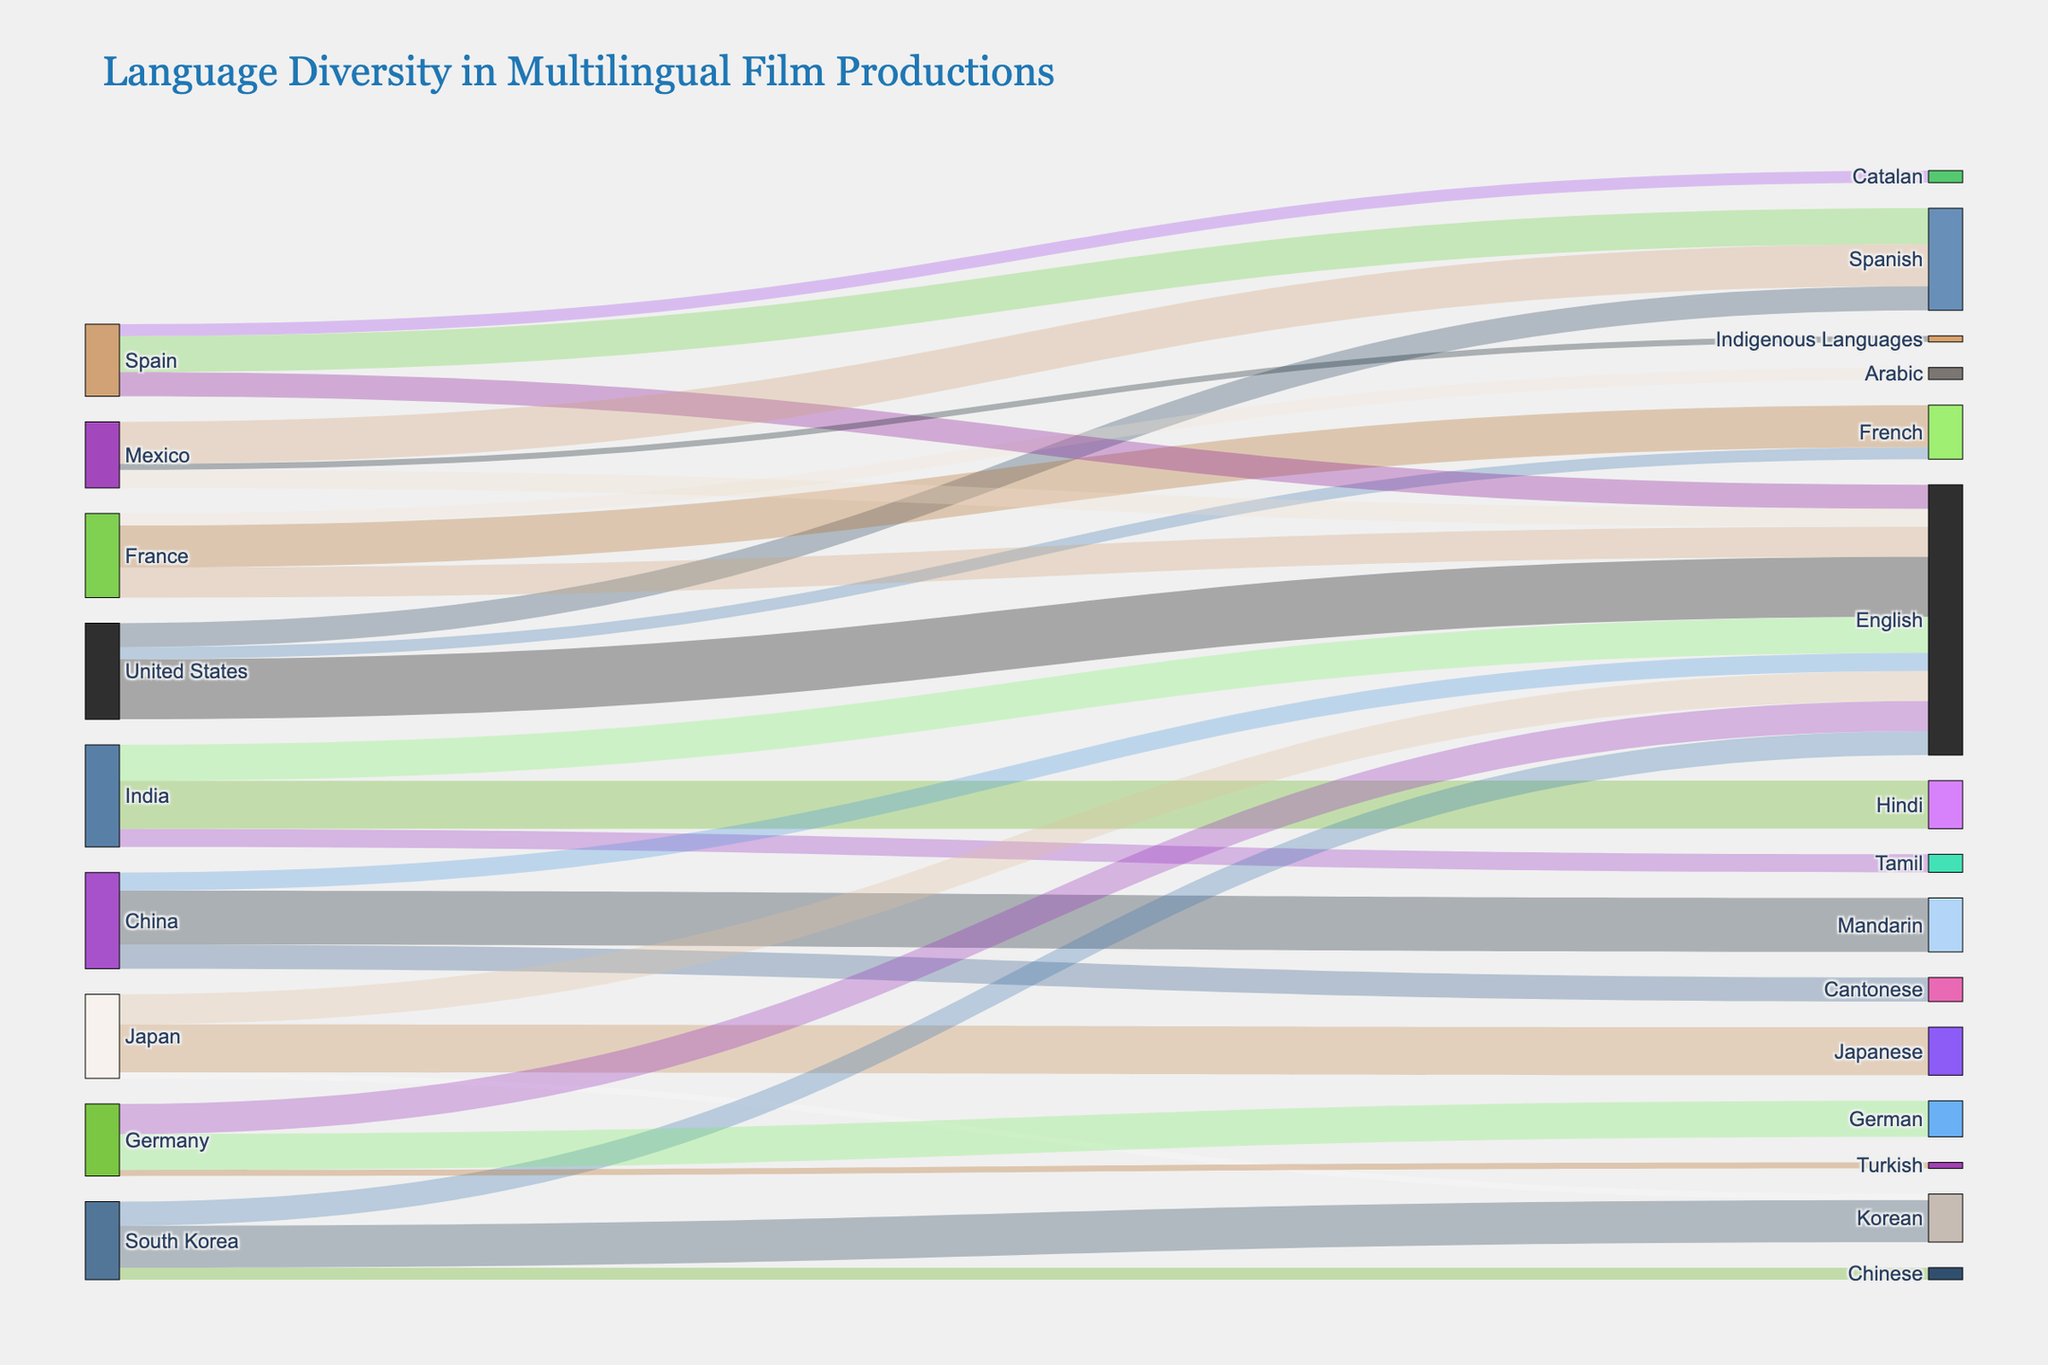What is the title of the figure? The title is typically displayed at the top of the figure and provides an overview of what the figure represents. Here, it shows the main context of the visual data.
Answer: Language Diversity in Multilingual Film Productions Which country has the highest representation of English-language films? From the Sankey diagram, we can follow the flow representing English language films and check which country's flow is the largest.
Answer: United States How many languages are represented in multilingual film productions originating from India? Identify the flows (links) stemming from India and count the different target languages connected. Each unique target in these links represents a language.
Answer: 3 Which country produces the most films in non-native languages, and what are those languages? Look at the flows originating from each country and find the one whose outgoing links to foreign languages (other than the native language) have the highest cumulative value. Sum the values for foreign language films for each country.
Answer: India; English and Tamil Compare the number of French-language films originating from France and the United States. Identify the flows from both France and the United States that target French-language films. Compare the values of these two flows.
Answer: France has more (35 from France vs. 10 from the United States) What is the total number of films produced in English? Identify all flows targeting English language films and sum their values to get the total number.
Answer: 160 Calculate the total number of multilingual films originating from China. Sum all the values of the flows originating from China, regardless of the target language. This involves adding the values for Mandarin, Cantonese, and English films produced in China.
Answer: 80 Which country produces the least films in a language other than its native language, and how many such films are produced? Look at each country and sum the values of all foreign language flows. Identify which country has the smallest total for non-native languages.
Answer: Mexico; 20 (15 in English and 5 in Indigenous Languages) Among India, France, and Germany, which country has the highest diversity in target languages? Count the unique target languages for each of these three countries and compare their numbers. Diversity can be measured by the number of different target languages.
Answer: India (3 target languages) Which country produces the highest number of films in Spanish, and what is that number? Identify the country with the highest value flow targeting Spanish-language films.
Answer: United States; 20 